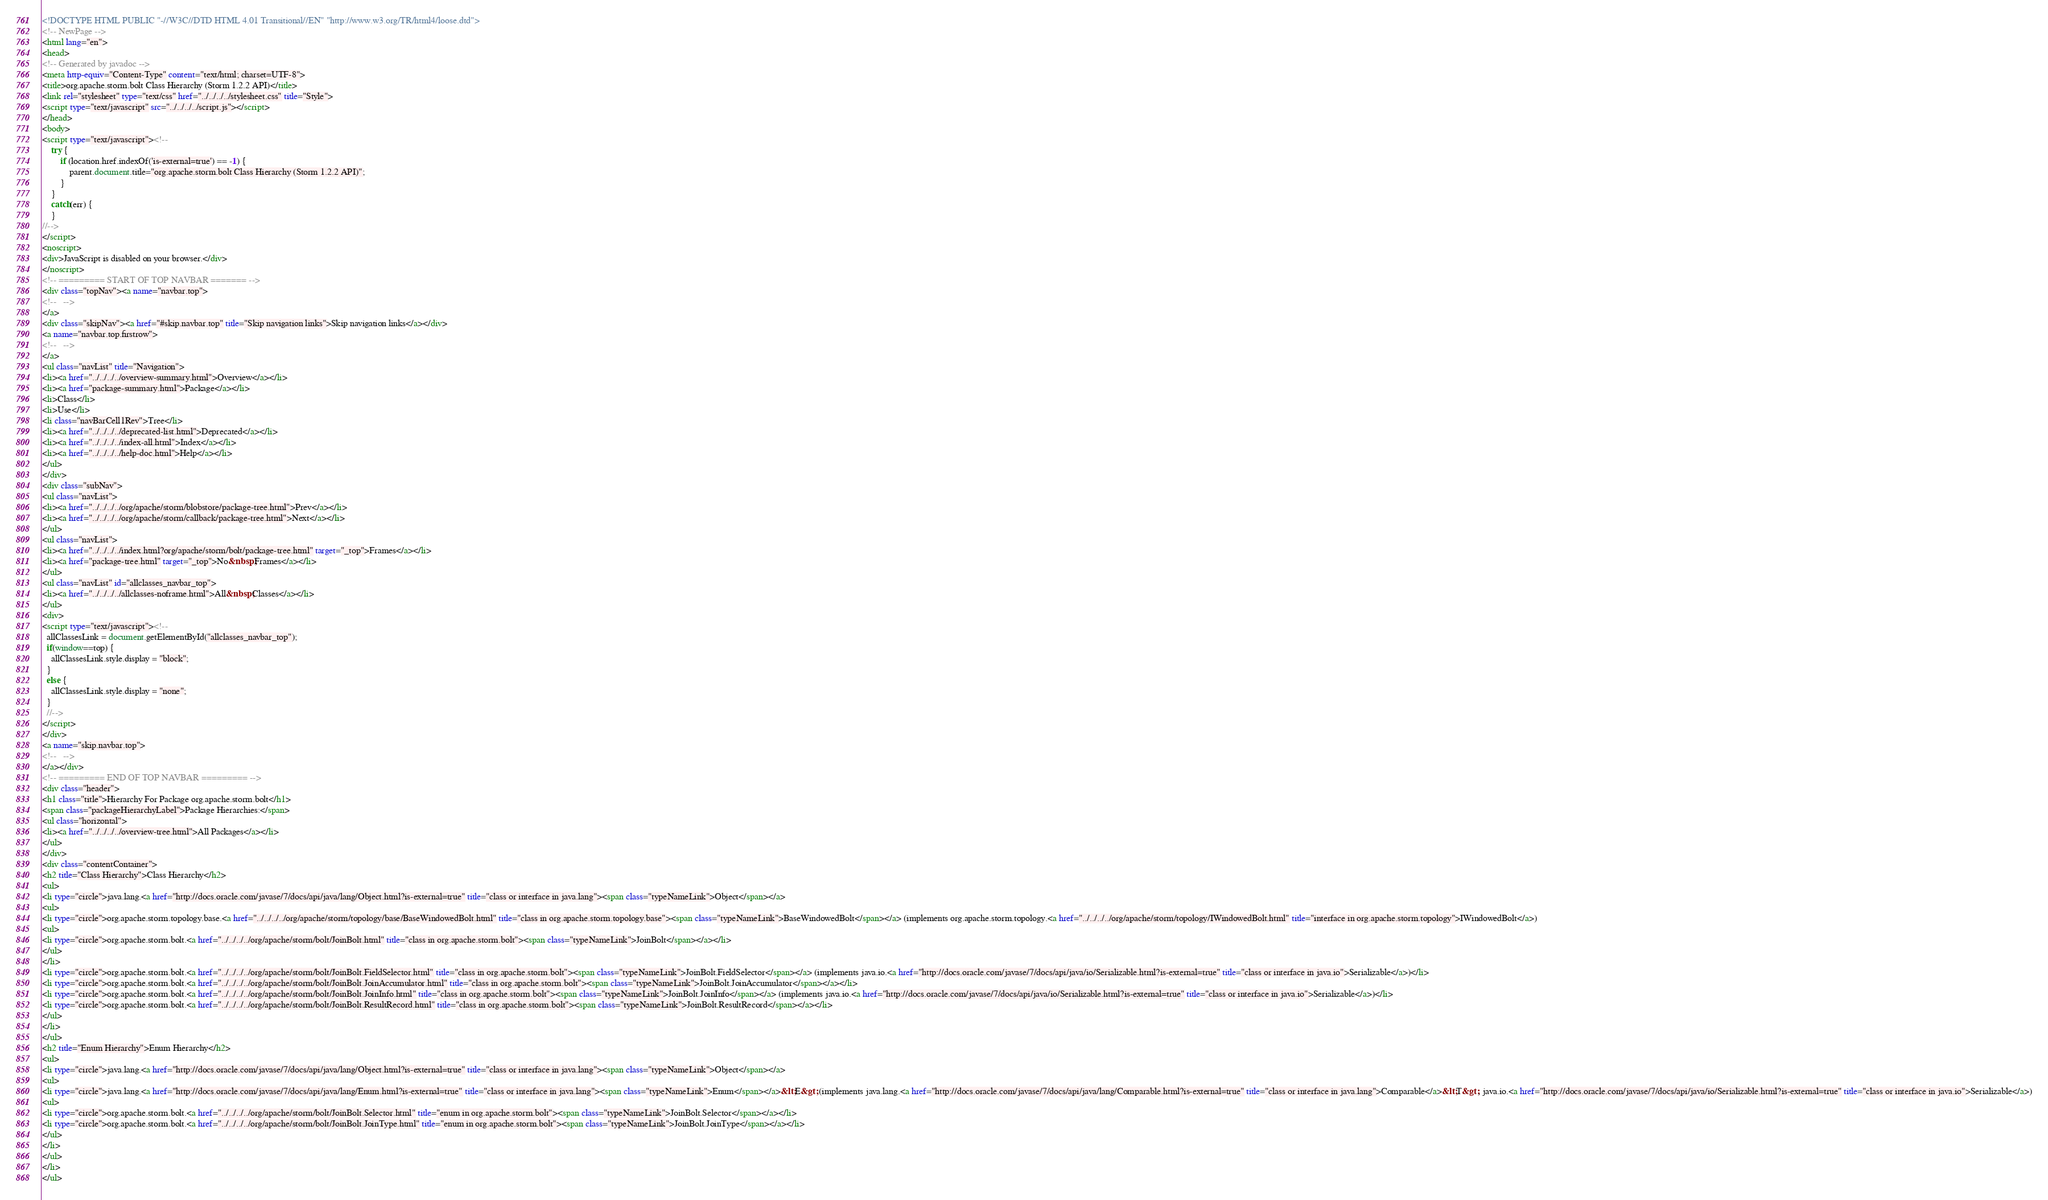Convert code to text. <code><loc_0><loc_0><loc_500><loc_500><_HTML_><!DOCTYPE HTML PUBLIC "-//W3C//DTD HTML 4.01 Transitional//EN" "http://www.w3.org/TR/html4/loose.dtd">
<!-- NewPage -->
<html lang="en">
<head>
<!-- Generated by javadoc -->
<meta http-equiv="Content-Type" content="text/html; charset=UTF-8">
<title>org.apache.storm.bolt Class Hierarchy (Storm 1.2.2 API)</title>
<link rel="stylesheet" type="text/css" href="../../../../stylesheet.css" title="Style">
<script type="text/javascript" src="../../../../script.js"></script>
</head>
<body>
<script type="text/javascript"><!--
    try {
        if (location.href.indexOf('is-external=true') == -1) {
            parent.document.title="org.apache.storm.bolt Class Hierarchy (Storm 1.2.2 API)";
        }
    }
    catch(err) {
    }
//-->
</script>
<noscript>
<div>JavaScript is disabled on your browser.</div>
</noscript>
<!-- ========= START OF TOP NAVBAR ======= -->
<div class="topNav"><a name="navbar.top">
<!--   -->
</a>
<div class="skipNav"><a href="#skip.navbar.top" title="Skip navigation links">Skip navigation links</a></div>
<a name="navbar.top.firstrow">
<!--   -->
</a>
<ul class="navList" title="Navigation">
<li><a href="../../../../overview-summary.html">Overview</a></li>
<li><a href="package-summary.html">Package</a></li>
<li>Class</li>
<li>Use</li>
<li class="navBarCell1Rev">Tree</li>
<li><a href="../../../../deprecated-list.html">Deprecated</a></li>
<li><a href="../../../../index-all.html">Index</a></li>
<li><a href="../../../../help-doc.html">Help</a></li>
</ul>
</div>
<div class="subNav">
<ul class="navList">
<li><a href="../../../../org/apache/storm/blobstore/package-tree.html">Prev</a></li>
<li><a href="../../../../org/apache/storm/callback/package-tree.html">Next</a></li>
</ul>
<ul class="navList">
<li><a href="../../../../index.html?org/apache/storm/bolt/package-tree.html" target="_top">Frames</a></li>
<li><a href="package-tree.html" target="_top">No&nbsp;Frames</a></li>
</ul>
<ul class="navList" id="allclasses_navbar_top">
<li><a href="../../../../allclasses-noframe.html">All&nbsp;Classes</a></li>
</ul>
<div>
<script type="text/javascript"><!--
  allClassesLink = document.getElementById("allclasses_navbar_top");
  if(window==top) {
    allClassesLink.style.display = "block";
  }
  else {
    allClassesLink.style.display = "none";
  }
  //-->
</script>
</div>
<a name="skip.navbar.top">
<!--   -->
</a></div>
<!-- ========= END OF TOP NAVBAR ========= -->
<div class="header">
<h1 class="title">Hierarchy For Package org.apache.storm.bolt</h1>
<span class="packageHierarchyLabel">Package Hierarchies:</span>
<ul class="horizontal">
<li><a href="../../../../overview-tree.html">All Packages</a></li>
</ul>
</div>
<div class="contentContainer">
<h2 title="Class Hierarchy">Class Hierarchy</h2>
<ul>
<li type="circle">java.lang.<a href="http://docs.oracle.com/javase/7/docs/api/java/lang/Object.html?is-external=true" title="class or interface in java.lang"><span class="typeNameLink">Object</span></a>
<ul>
<li type="circle">org.apache.storm.topology.base.<a href="../../../../org/apache/storm/topology/base/BaseWindowedBolt.html" title="class in org.apache.storm.topology.base"><span class="typeNameLink">BaseWindowedBolt</span></a> (implements org.apache.storm.topology.<a href="../../../../org/apache/storm/topology/IWindowedBolt.html" title="interface in org.apache.storm.topology">IWindowedBolt</a>)
<ul>
<li type="circle">org.apache.storm.bolt.<a href="../../../../org/apache/storm/bolt/JoinBolt.html" title="class in org.apache.storm.bolt"><span class="typeNameLink">JoinBolt</span></a></li>
</ul>
</li>
<li type="circle">org.apache.storm.bolt.<a href="../../../../org/apache/storm/bolt/JoinBolt.FieldSelector.html" title="class in org.apache.storm.bolt"><span class="typeNameLink">JoinBolt.FieldSelector</span></a> (implements java.io.<a href="http://docs.oracle.com/javase/7/docs/api/java/io/Serializable.html?is-external=true" title="class or interface in java.io">Serializable</a>)</li>
<li type="circle">org.apache.storm.bolt.<a href="../../../../org/apache/storm/bolt/JoinBolt.JoinAccumulator.html" title="class in org.apache.storm.bolt"><span class="typeNameLink">JoinBolt.JoinAccumulator</span></a></li>
<li type="circle">org.apache.storm.bolt.<a href="../../../../org/apache/storm/bolt/JoinBolt.JoinInfo.html" title="class in org.apache.storm.bolt"><span class="typeNameLink">JoinBolt.JoinInfo</span></a> (implements java.io.<a href="http://docs.oracle.com/javase/7/docs/api/java/io/Serializable.html?is-external=true" title="class or interface in java.io">Serializable</a>)</li>
<li type="circle">org.apache.storm.bolt.<a href="../../../../org/apache/storm/bolt/JoinBolt.ResultRecord.html" title="class in org.apache.storm.bolt"><span class="typeNameLink">JoinBolt.ResultRecord</span></a></li>
</ul>
</li>
</ul>
<h2 title="Enum Hierarchy">Enum Hierarchy</h2>
<ul>
<li type="circle">java.lang.<a href="http://docs.oracle.com/javase/7/docs/api/java/lang/Object.html?is-external=true" title="class or interface in java.lang"><span class="typeNameLink">Object</span></a>
<ul>
<li type="circle">java.lang.<a href="http://docs.oracle.com/javase/7/docs/api/java/lang/Enum.html?is-external=true" title="class or interface in java.lang"><span class="typeNameLink">Enum</span></a>&lt;E&gt; (implements java.lang.<a href="http://docs.oracle.com/javase/7/docs/api/java/lang/Comparable.html?is-external=true" title="class or interface in java.lang">Comparable</a>&lt;T&gt;, java.io.<a href="http://docs.oracle.com/javase/7/docs/api/java/io/Serializable.html?is-external=true" title="class or interface in java.io">Serializable</a>)
<ul>
<li type="circle">org.apache.storm.bolt.<a href="../../../../org/apache/storm/bolt/JoinBolt.Selector.html" title="enum in org.apache.storm.bolt"><span class="typeNameLink">JoinBolt.Selector</span></a></li>
<li type="circle">org.apache.storm.bolt.<a href="../../../../org/apache/storm/bolt/JoinBolt.JoinType.html" title="enum in org.apache.storm.bolt"><span class="typeNameLink">JoinBolt.JoinType</span></a></li>
</ul>
</li>
</ul>
</li>
</ul></code> 